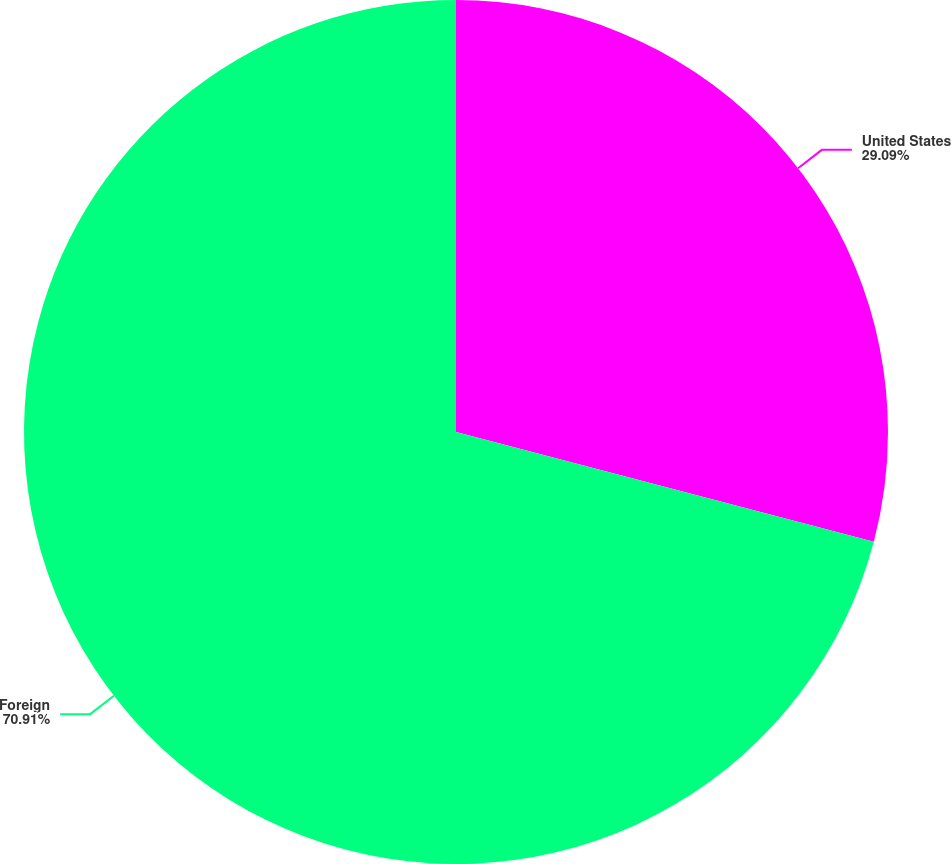<chart> <loc_0><loc_0><loc_500><loc_500><pie_chart><fcel>United States<fcel>Foreign<nl><fcel>29.09%<fcel>70.91%<nl></chart> 